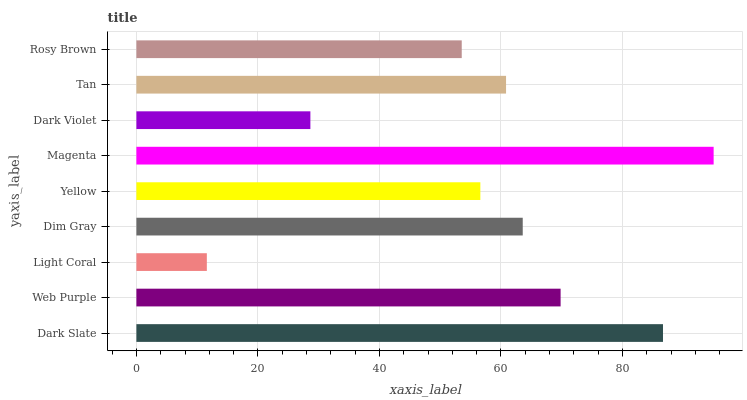Is Light Coral the minimum?
Answer yes or no. Yes. Is Magenta the maximum?
Answer yes or no. Yes. Is Web Purple the minimum?
Answer yes or no. No. Is Web Purple the maximum?
Answer yes or no. No. Is Dark Slate greater than Web Purple?
Answer yes or no. Yes. Is Web Purple less than Dark Slate?
Answer yes or no. Yes. Is Web Purple greater than Dark Slate?
Answer yes or no. No. Is Dark Slate less than Web Purple?
Answer yes or no. No. Is Tan the high median?
Answer yes or no. Yes. Is Tan the low median?
Answer yes or no. Yes. Is Dim Gray the high median?
Answer yes or no. No. Is Yellow the low median?
Answer yes or no. No. 